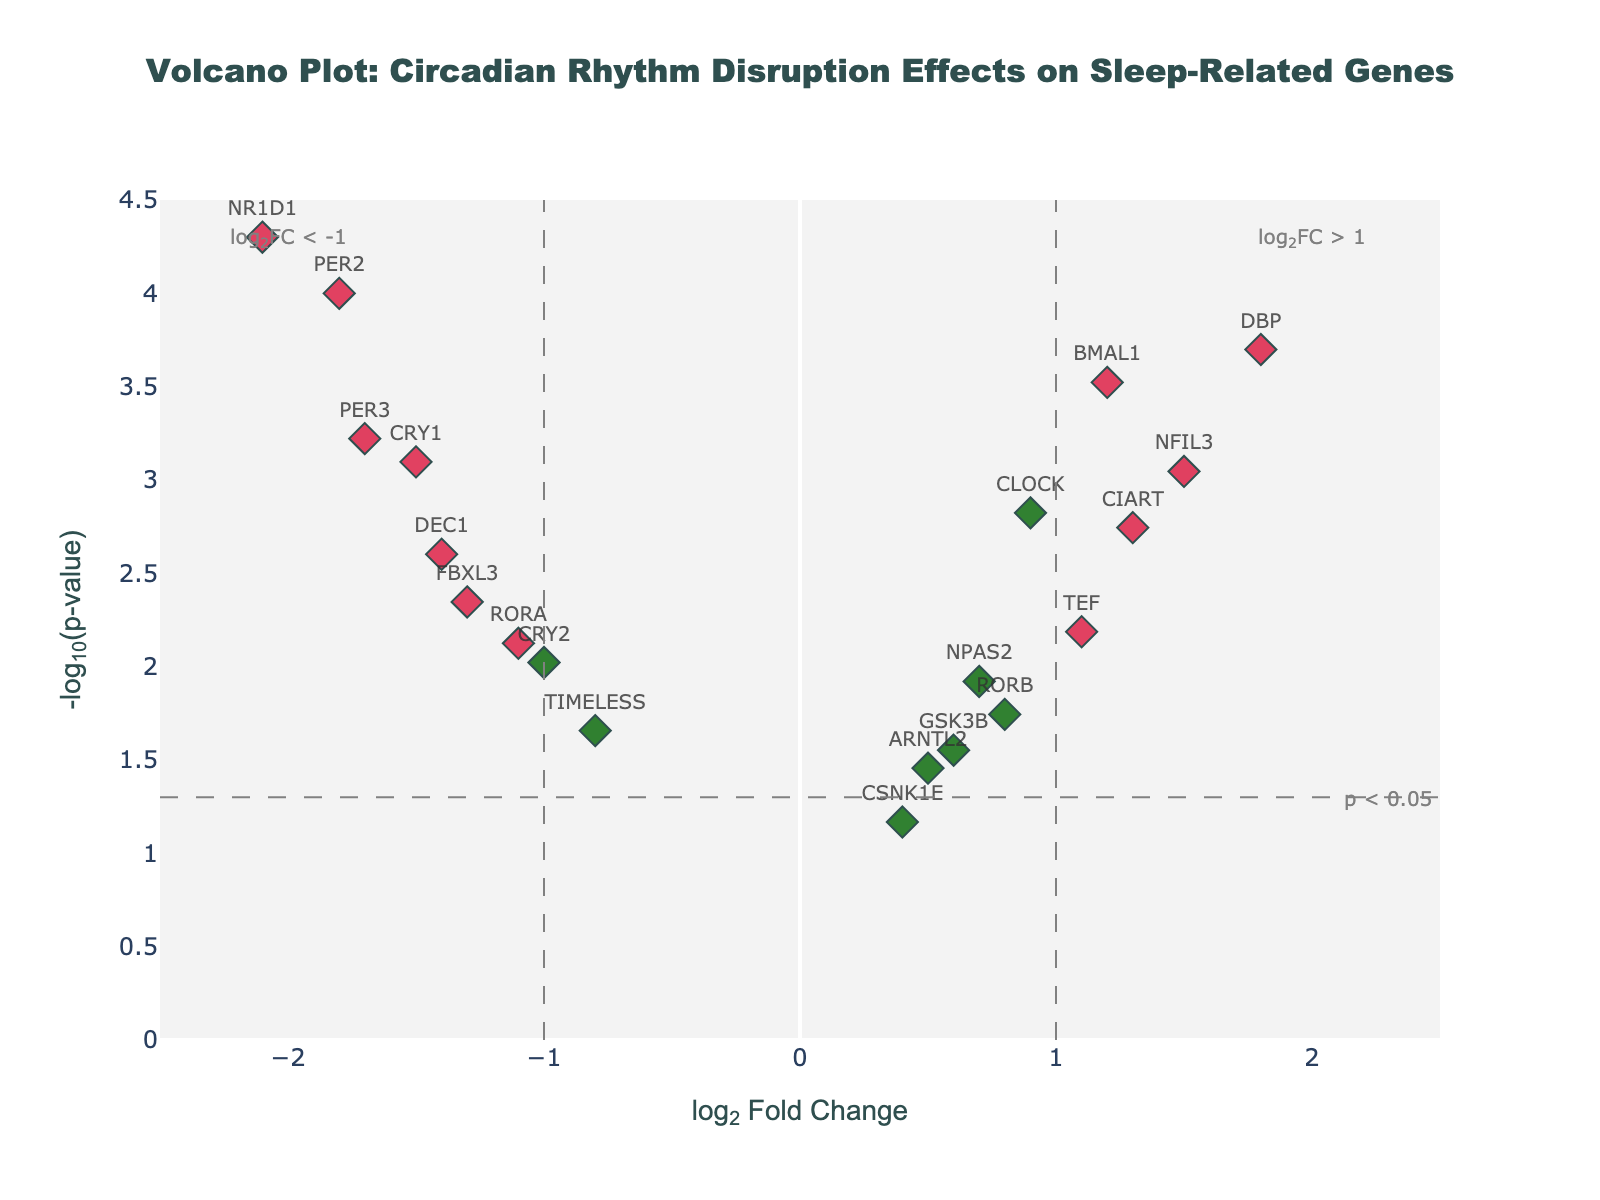What is the title of the plot? The title of the plot is displayed at the top center. It reads "Volcano Plot: Circadian Rhythm Disruption Effects on Sleep-Related Genes".
Answer: Volcano Plot: Circadian Rhythm Disruption Effects on Sleep-Related Genes What are the axes labels? The x-axis is labeled "log₂ Fold Change" and the y-axis is labeled "-log₁₀(p-value)". These labels are used to describe the dimensions of the data being plotted.
Answer: log₂ Fold Change, -log₁₀(p-value) What is the color of the most differentially expressed gene? The most differentially expressed gene has the highest absolute log₂ fold change. In this case, it is NR1D1 with a log₂ fold change of -2.1. The color representing significant differential expression is red.
Answer: red How many genes have a log₂ fold change greater than 1? Look for points to the right of the vertical threshold line at log₂FC=1. These points include CLOCK, BMAL1, DBP, CIART, NFIL3, and TEF. Count these points.
Answer: 6 Which gene has the lowest p-value? The p-value is represented on the y-axis by -log₁₀(p-value). The gene with the highest y-axis value will have the lowest p-value. In this case, the gene is NR1D1.
Answer: NR1D1 Which gene has the smallest log₂ fold change but is still significant? A significant gene will have its color in red and must lie outside the vertical thresholds but inside the horizontal threshold. TIMELESS, which has the smallest fold change (-0.8) among the significant genes, is such a gene.
Answer: TIMELESS What is the fold change and p-value of gene CRY1? Locate the point labeled CRY1 on the plot. The hover text indicates its attributes: log₂FC = -1.5, p-value = 0.0008.
Answer: log₂FC = -1.5, p-value = 0.0008 How many genes are considered statistically significant? Statistically significant genes are colored red or blue. Count all such genes. nly count points with colors red (significant differential expression) and not gray (non-significant). There are 10 such genes.
Answer: 10 Among the genes plotted, how many have p-values less than the threshold but are not differentially expressed? These genes would have points above the horizontal threshold line (p < 0.05) but within the vertical threshold lines at log₂FC = ±1. There are 5 such genes: NPAS2, TIMELESS, CSNK1E, GSK3B, and RORA.
Answer: 5 Which two genes show the highest absolute log₂ fold changes but in opposite directions? By examining the extreme left and right ends of the plot, we identify NR1D1 (-2.1) and DBP (1.8) as the genes with the highest absolute log₂ fold changes in opposite directions.
Answer: NR1D1 and DBP 